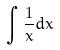Convert formula to latex. <formula><loc_0><loc_0><loc_500><loc_500>\int \frac { 1 } { x } d x</formula> 